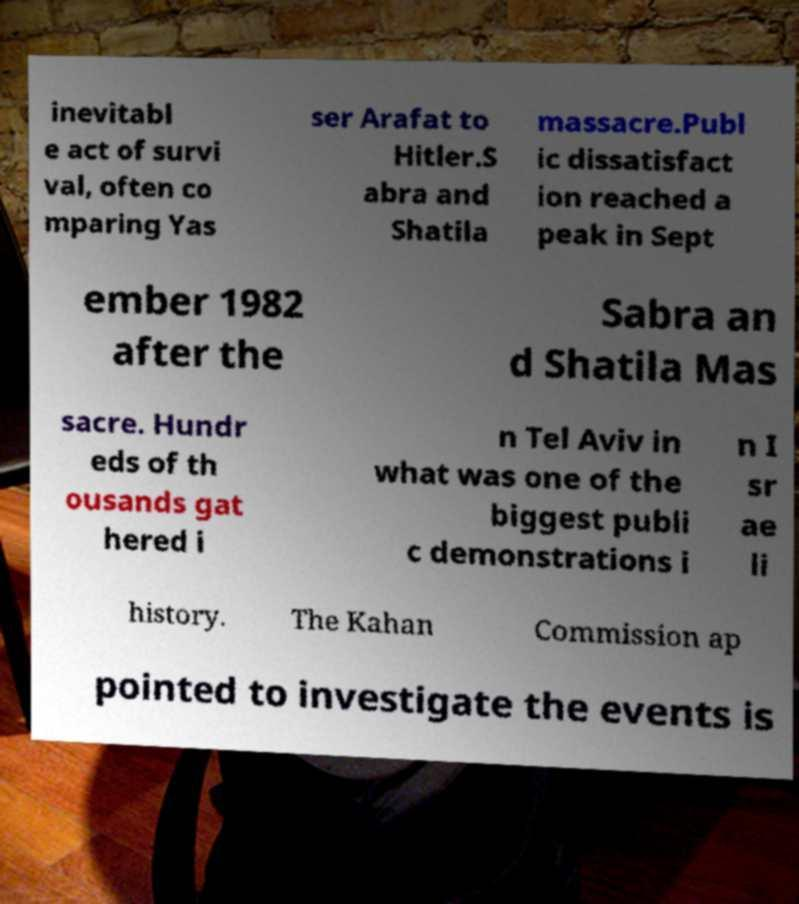I need the written content from this picture converted into text. Can you do that? inevitabl e act of survi val, often co mparing Yas ser Arafat to Hitler.S abra and Shatila massacre.Publ ic dissatisfact ion reached a peak in Sept ember 1982 after the Sabra an d Shatila Mas sacre. Hundr eds of th ousands gat hered i n Tel Aviv in what was one of the biggest publi c demonstrations i n I sr ae li history. The Kahan Commission ap pointed to investigate the events is 